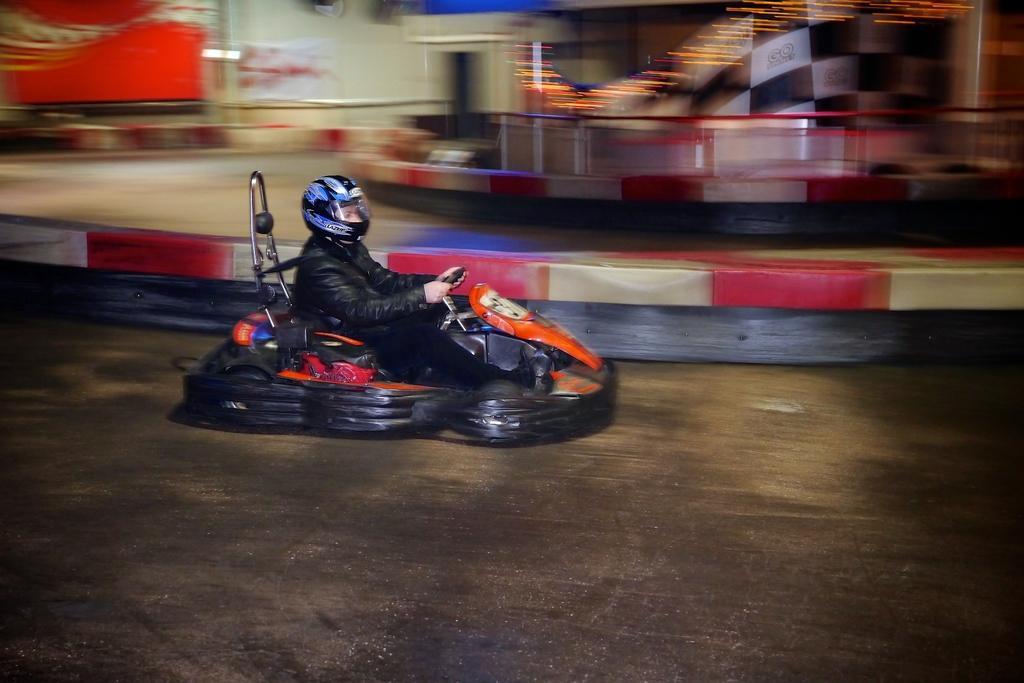Could you give a brief overview of what you see in this image? In this image we can see a person wearing the helmet and riding and the background is blurred with a barrier, path, wall, banner and at the bottom we can see the road. 